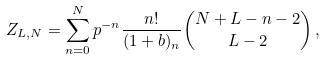<formula> <loc_0><loc_0><loc_500><loc_500>Z _ { L , N } = \sum _ { n = 0 } ^ { N } p ^ { - n } \frac { n ! } { ( 1 + b ) _ { n } } { N + L - n - 2 \choose L - 2 } \, ,</formula> 